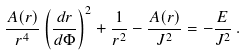<formula> <loc_0><loc_0><loc_500><loc_500>\frac { A ( r ) } { r ^ { 4 } } \left ( \frac { d r } { d \Phi } \right ) ^ { 2 } + \frac { 1 } { r ^ { 2 } } - \frac { A ( r ) } { J ^ { 2 } } = - \frac { E } { J ^ { 2 } } \, .</formula> 